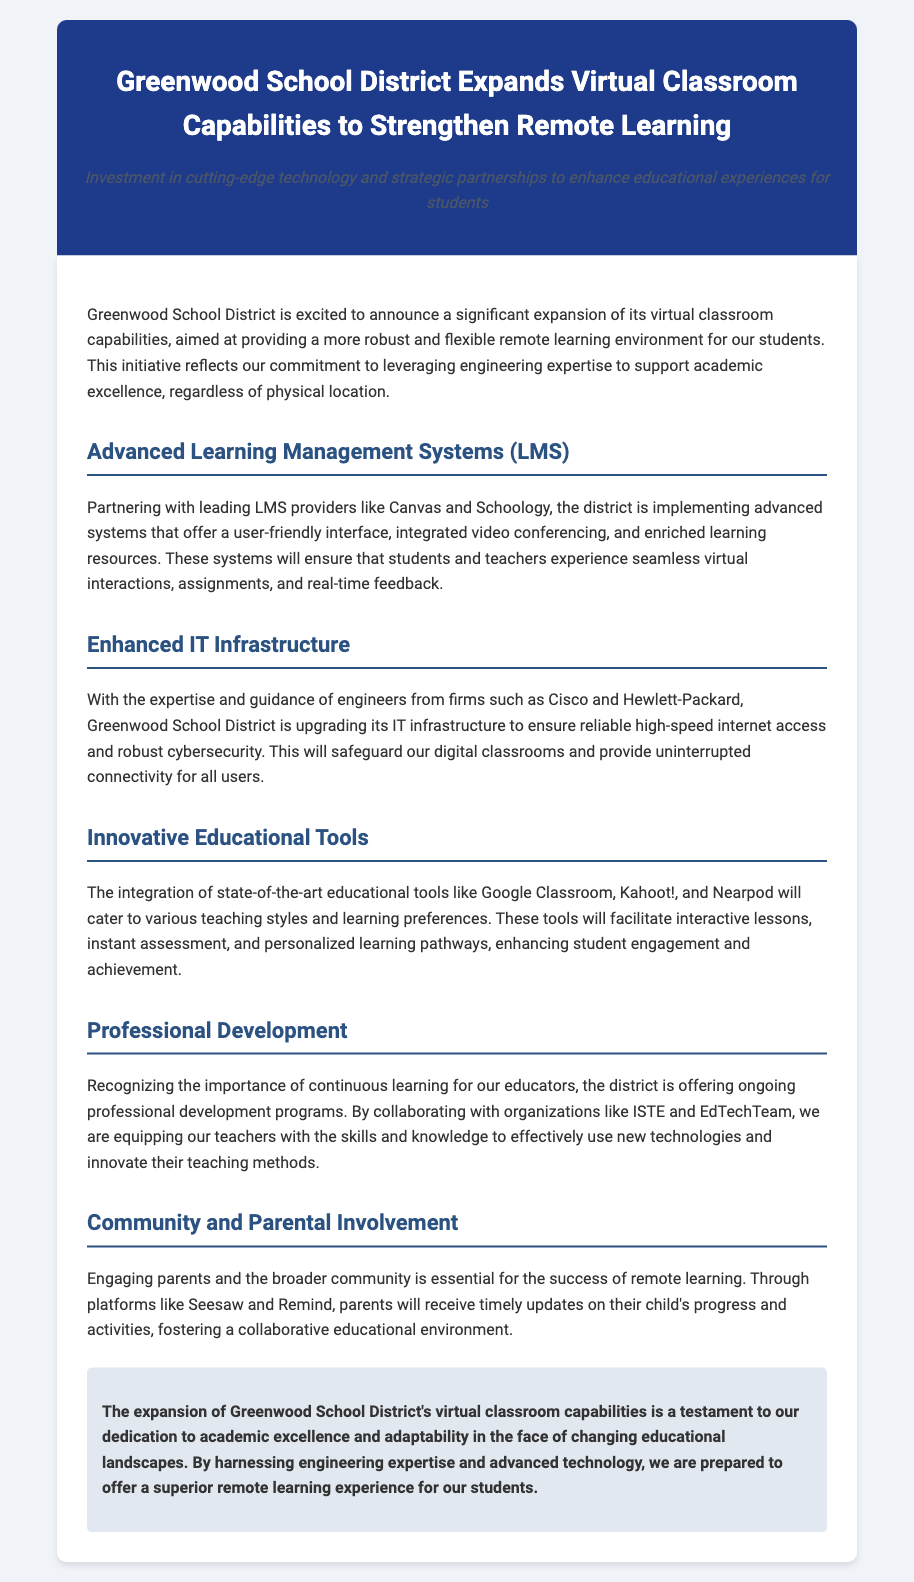What is the name of the school district? The document clearly indicates that the district involved in the expansion is named Greenwood School District.
Answer: Greenwood School District What technology companies are mentioned in the press release? The press release highlights partnerships with Cisco and Hewlett-Packard, among others, in enhancing IT infrastructure.
Answer: Cisco and Hewlett-Packard What are the names of the advanced LMS providers? The text specifically mentions Canvas and Schoology as the leading LMS providers that Greenwood School District is partnering with.
Answer: Canvas and Schoology How many educational tools are listed in the document? The document lists three innovative educational tools: Google Classroom, Kahoot!, and Nearpod.
Answer: Three What is the primary goal of the initiative? The press release emphasizes the goal of providing a more robust and flexible remote learning environment for students.
Answer: More robust and flexible remote learning environment What role do professional development programs play according to the document? It is stated that professional development programs are offered to equip teachers with the necessary skills and knowledge to effectively use new technologies.
Answer: Equipping teachers with skills How will parents be engaged in the remote learning process? The document explains that parents will receive timely updates on their child's progress through platforms like Seesaw and Remind.
Answer: Seesaw and Remind What overarching theme does the conclusion of the press release convey? The conclusion emphasizes dedication to academic excellence and adaptability in the changing educational landscape.
Answer: Dedication to academic excellence and adaptability 